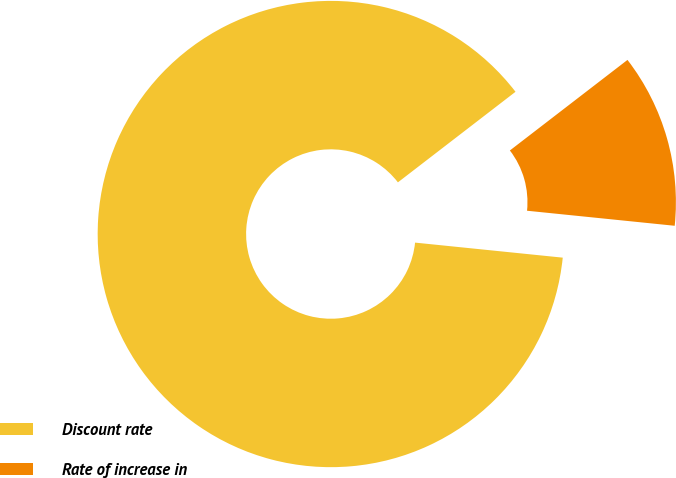<chart> <loc_0><loc_0><loc_500><loc_500><pie_chart><fcel>Discount rate<fcel>Rate of increase in<nl><fcel>87.94%<fcel>12.06%<nl></chart> 